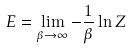Convert formula to latex. <formula><loc_0><loc_0><loc_500><loc_500>E = \lim _ { \beta \rightarrow \infty } - \frac { 1 } { \beta } \ln Z</formula> 